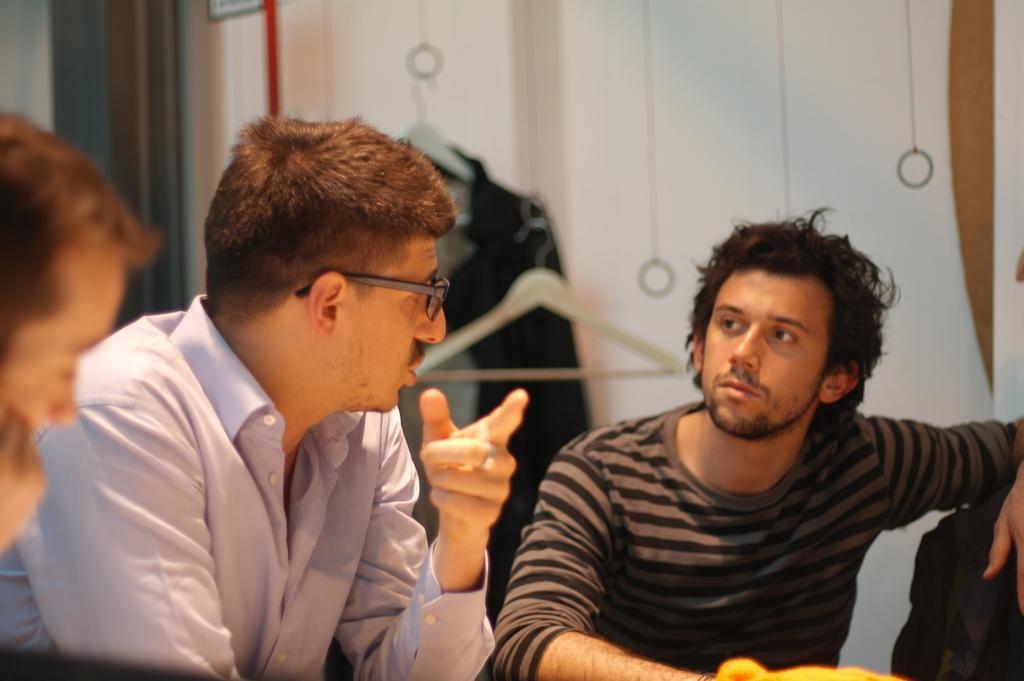In one or two sentences, can you explain what this image depicts? In this image we can see group of people are sitting, at the back there is a suit hanging to the hanger, there is a wall. 